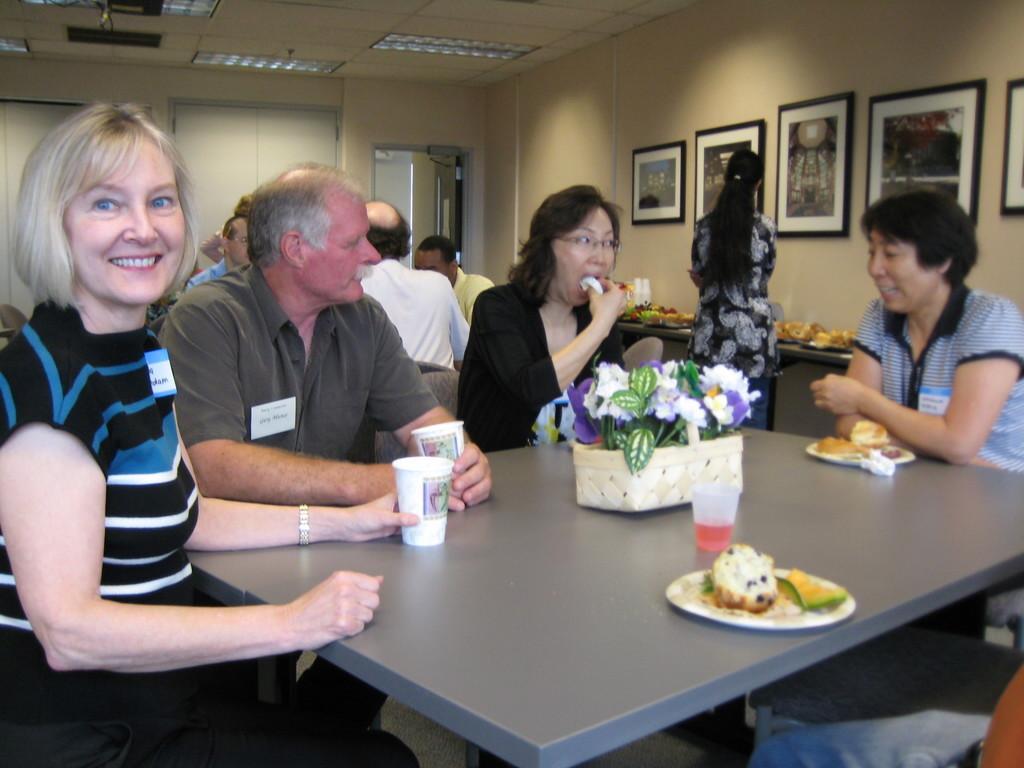In one or two sentences, can you explain what this image depicts? In this image, There is a table which is in ash color on that table there is a white color basket in that there are some artificial flowers, There is a plate on the table which contains some food items, There are some people siting on the chairs around the table, in the background there are some people sitting, In the right side there is a girl standing and there is a wall in yellow color and there are some pictures on the wall, In the top there is a white color wall, There is a white color door in the left side background. 